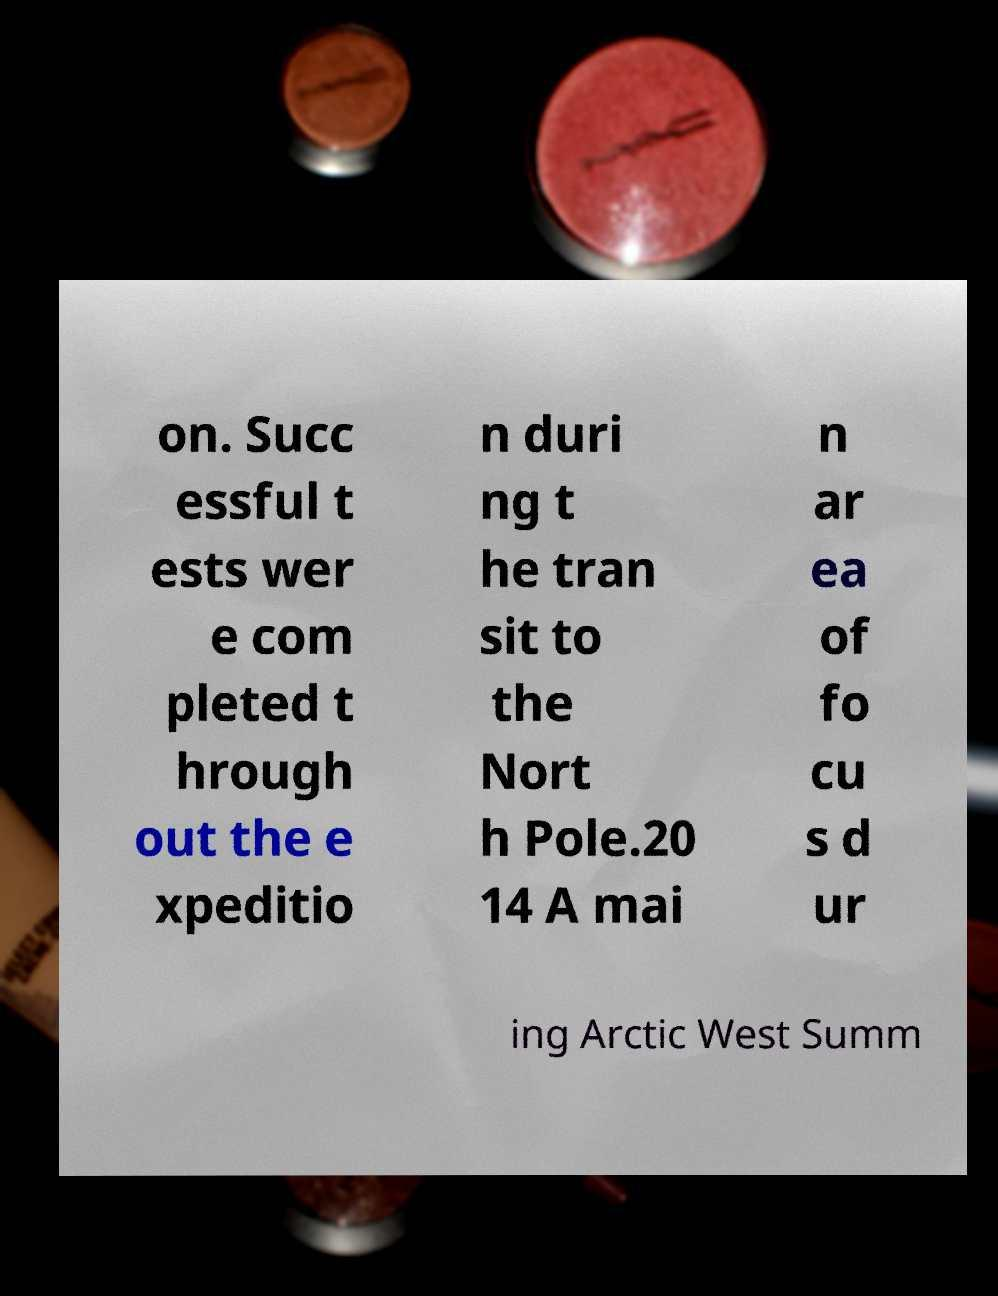Can you accurately transcribe the text from the provided image for me? on. Succ essful t ests wer e com pleted t hrough out the e xpeditio n duri ng t he tran sit to the Nort h Pole.20 14 A mai n ar ea of fo cu s d ur ing Arctic West Summ 